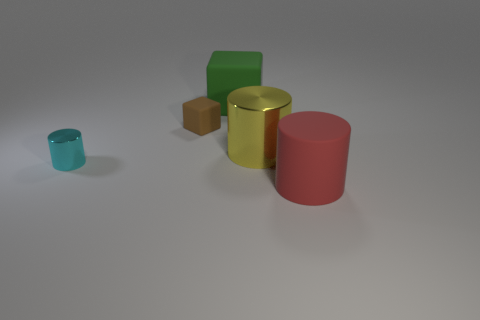Are there any other things that are the same color as the small block?
Ensure brevity in your answer.  No. What color is the big metallic object?
Keep it short and to the point. Yellow. Do the small metallic thing and the large block have the same color?
Offer a very short reply. No. There is a large cylinder that is behind the big red cylinder; what number of big yellow metallic things are left of it?
Ensure brevity in your answer.  0. There is a big rubber thing behind the large red rubber thing; is it the same shape as the big rubber thing in front of the yellow cylinder?
Keep it short and to the point. No. Is there a tiny purple cylinder made of the same material as the large yellow thing?
Ensure brevity in your answer.  No. How many matte objects are either small brown blocks or green cubes?
Give a very brief answer. 2. What shape is the tiny object that is behind the shiny cylinder to the left of the big yellow metallic cylinder?
Make the answer very short. Cube. Are there fewer shiny objects that are behind the green rubber cube than large things?
Your response must be concise. Yes. What shape is the tiny rubber thing?
Keep it short and to the point. Cube. 